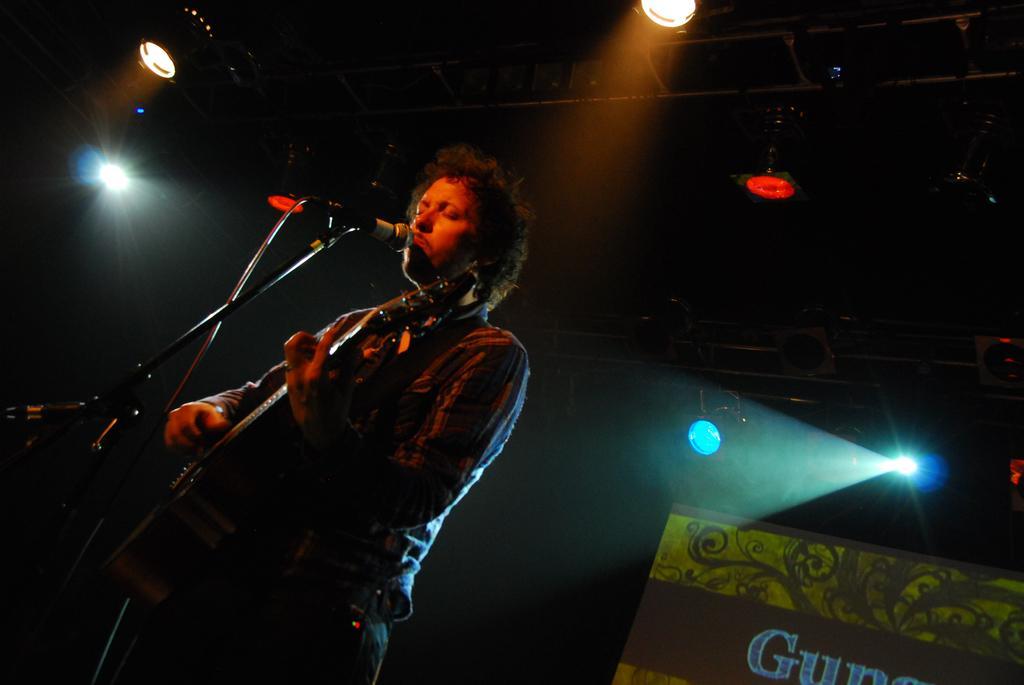Could you give a brief overview of what you see in this image? There is a person holding a guitar and playing. In front of him there is a mic and mic stand. On the right corner there is a banner. On the top there are lights and rods. 